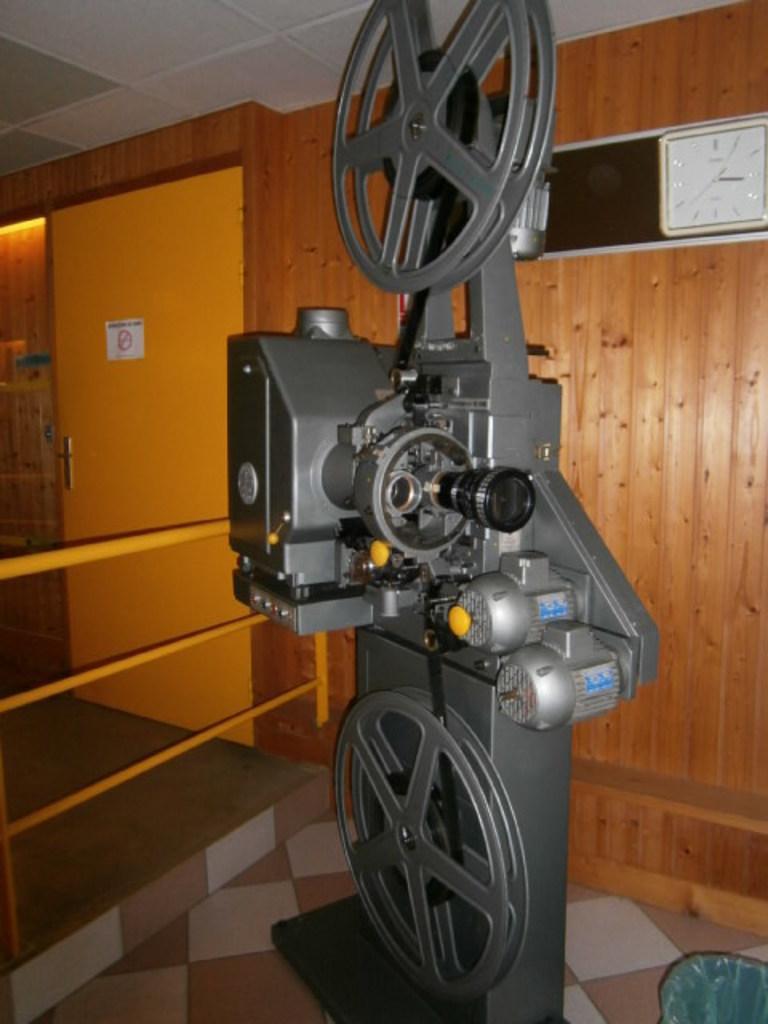Can you describe this image briefly? In this image in the center there is one machine and in the background there is a wooden wall, door and one clock. At the bottom there is a floor, at the top there is ceiling. 